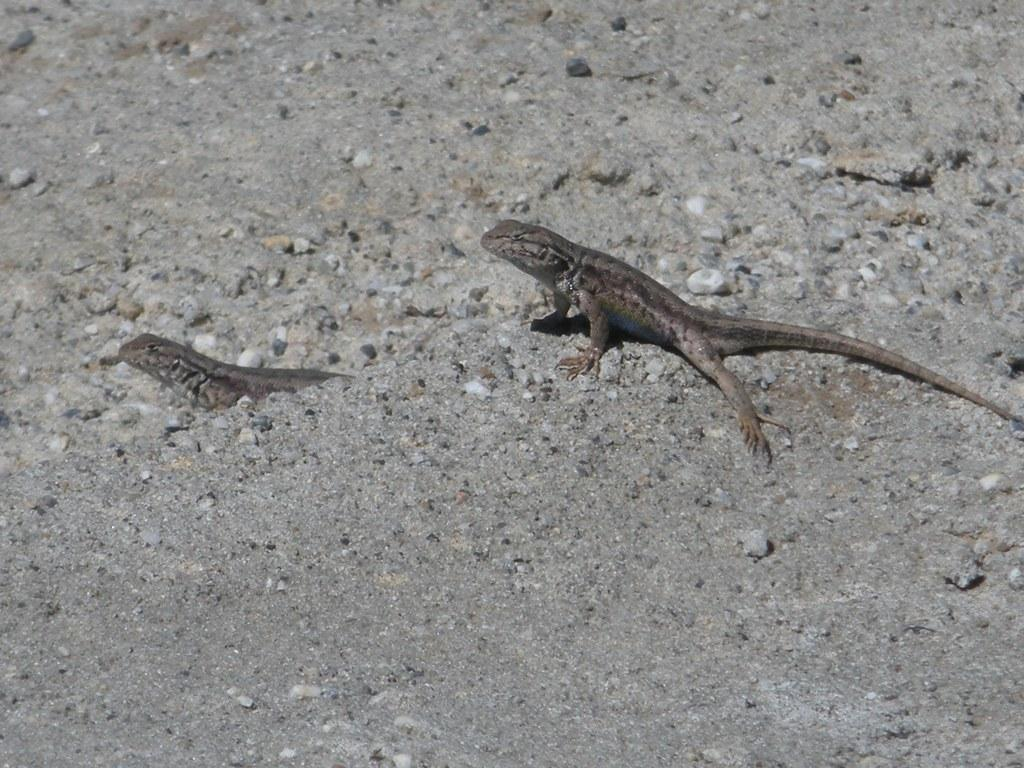How many lizards are present in the image? There are two lizards in the image. Where are the lizards located? The lizards are on the ground. What else can be seen in the image besides the lizards? There are small stones visible in the image. What type of meal is being prepared by the beast in the image? There is no beast or meal preparation present in the image; it features two lizards on the ground and small stones. What activity are the lizards engaged in during the image? The image does not show the lizards engaged in any specific activity; they are simply located on the ground. 